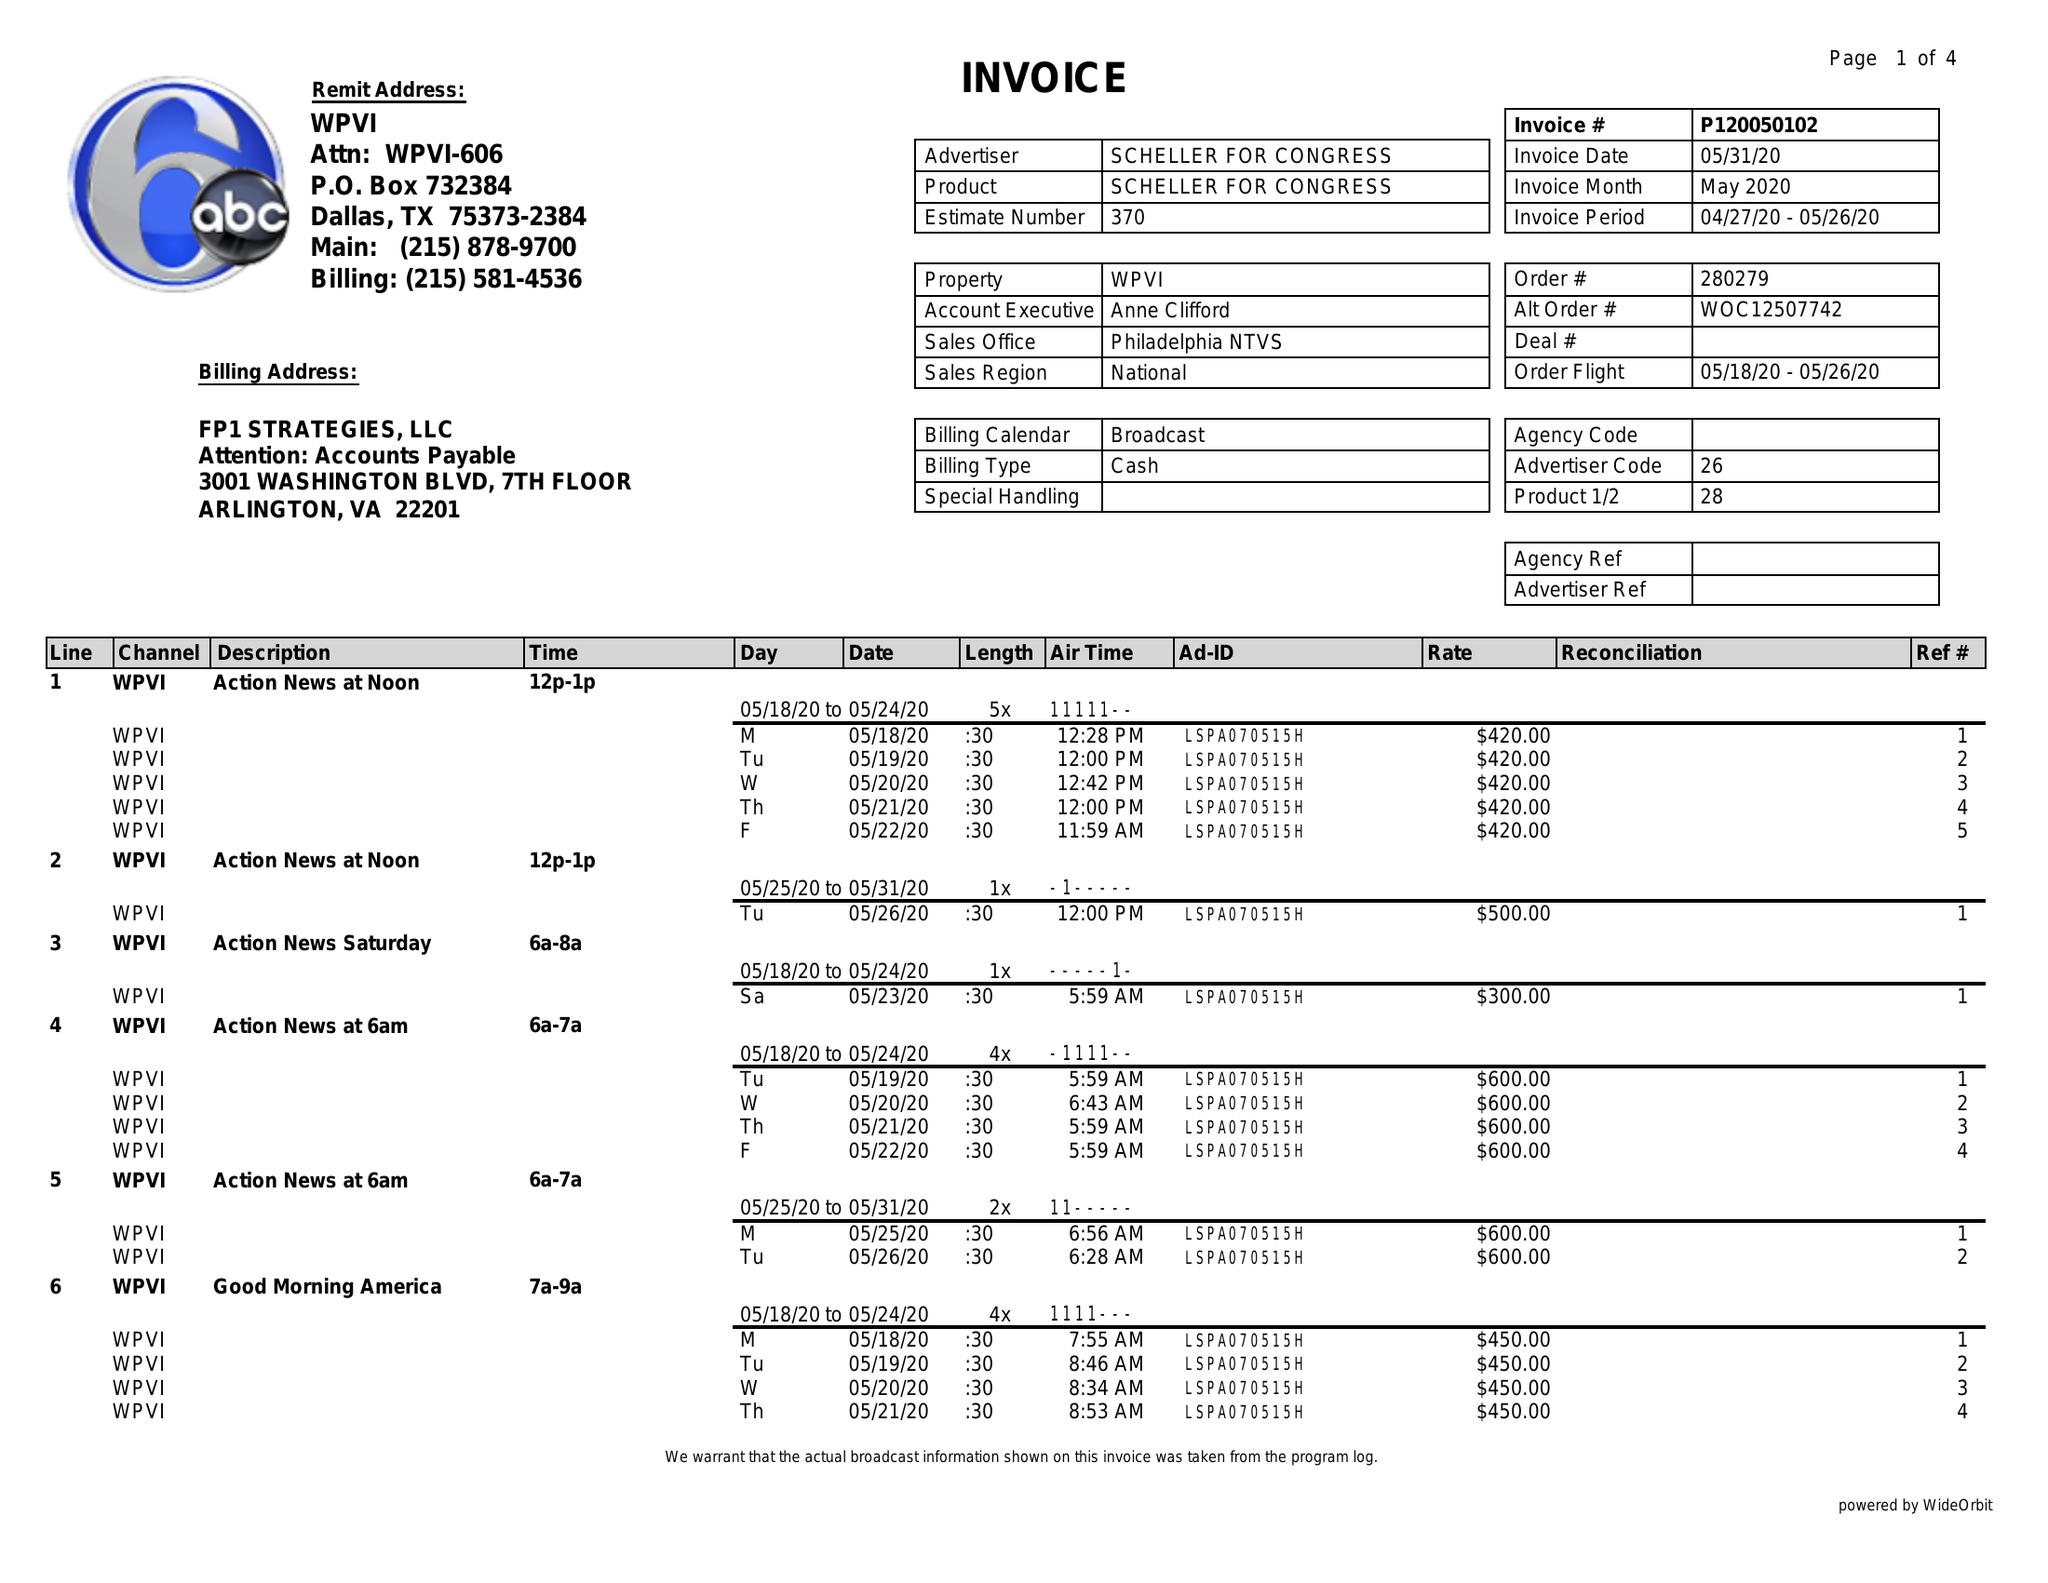What is the value for the flight_from?
Answer the question using a single word or phrase. 05/18/20 